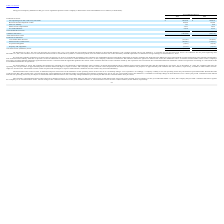From Ringcentral's financial document, What is the respective net increase in the valuation allowance for the years ended December 31, 2019 and 2018? The document shows two values: $86.0 million and $18.2 million. From the document: "nded December 31, 2019 and 2018 was an increase of $86.0 million, $18.2 million, respectively. 1, 2019 and 2018 was an increase of $86.0 million, $18...." Also, What are the respective net operating loss and credit carry-forwards for 2018 and 2019? The document shows two values: $109,812 and $196,930 (in thousands). From the document: "Net operating loss and credit carry-forwards $ 196,930 $ 109,812 rating loss and credit carry-forwards $ 196,930 $ 109,812..." Also, What are the respective research and development credits in 2018 and 2019? The document shows two values: 16,380 and 24,452 (in thousands). From the document: "Research and development credits 24,452 16,380 Research and development credits 24,452 16,380..." Also, can you calculate: What is the percentage change in the company's net operating loss and credit carry-forwards between 2018 and 2019? To answer this question, I need to perform calculations using the financial data. The calculation is: (196,930 - 109,812)/109,812 , which equals 79.33 (percentage). This is based on the information: "Net operating loss and credit carry-forwards $ 196,930 $ 109,812 rating loss and credit carry-forwards $ 196,930 $ 109,812..." The key data points involved are: 109,812, 196,930. Also, can you calculate: What is the percentage change in the company's sales tax liability between 2018 and 2019? To answer this question, I need to perform calculations using the financial data. The calculation is: (157 - 258)/258 , which equals -39.15 (percentage). This is based on the information: "Sales tax liability 157 258 Sales tax liability 157 258..." The key data points involved are: 157, 258. Also, can you calculate: What is the average share based compensation in 2018 and 2019? To answer this question, I need to perform calculations using the financial data. The calculation is: (5,937 + 5,435)/2, which equals 5686 (in thousands). This is based on the information: "Share-based compensation 5,937 5,435 Share-based compensation 5,937 5,435..." The key data points involved are: 5,435, 5,937. 